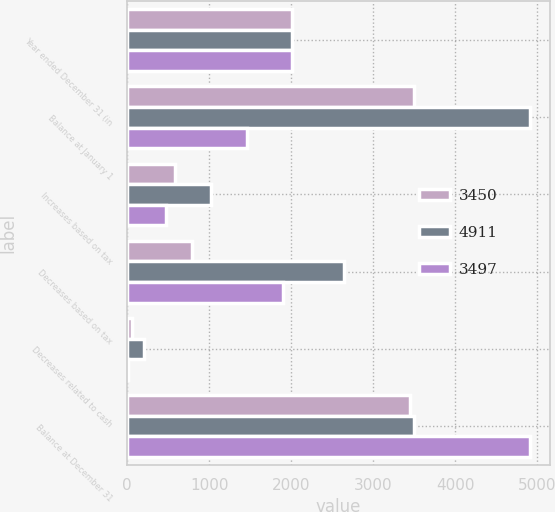<chart> <loc_0><loc_0><loc_500><loc_500><stacked_bar_chart><ecel><fcel>Year ended December 31 (in<fcel>Balance at January 1<fcel>Increases based on tax<fcel>Decreases based on tax<fcel>Decreases related to cash<fcel>Balance at December 31<nl><fcel>3450<fcel>2016<fcel>3497<fcel>583<fcel>785<fcel>56<fcel>3450<nl><fcel>4911<fcel>2015<fcel>4911<fcel>1028<fcel>2646<fcel>204<fcel>3497<nl><fcel>3497<fcel>2014<fcel>1465<fcel>477<fcel>1902<fcel>9<fcel>4911<nl></chart> 